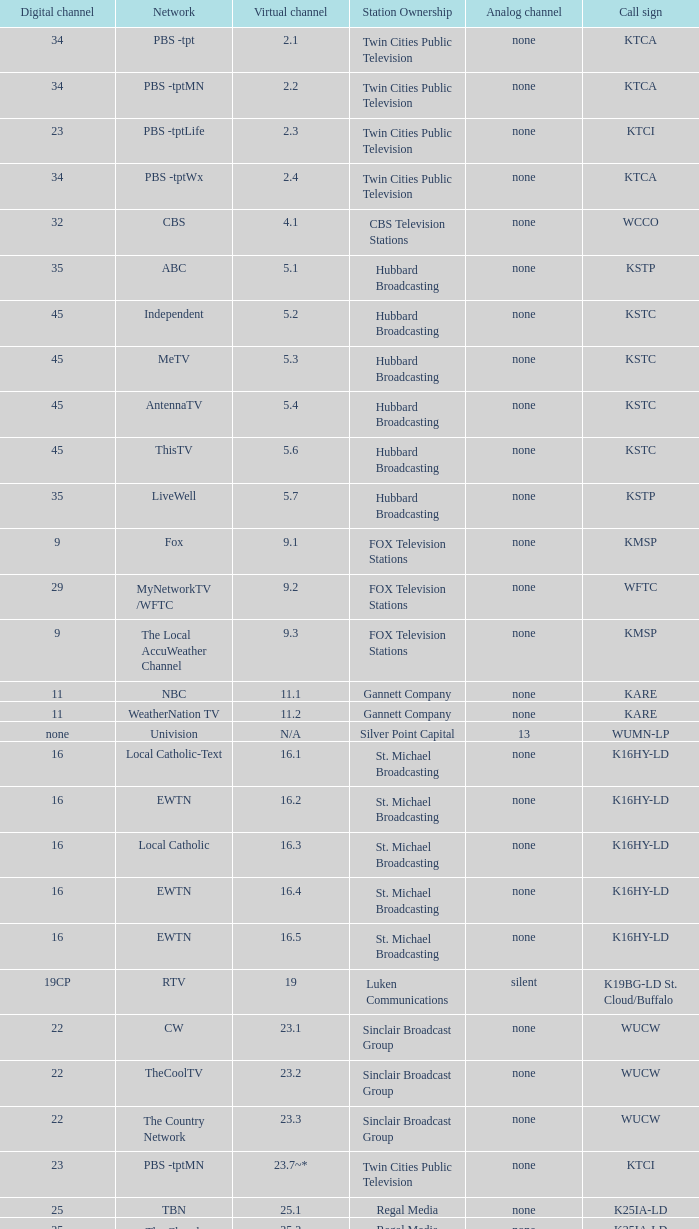Virtual channel of 16.5 has what call sign? K16HY-LD. 